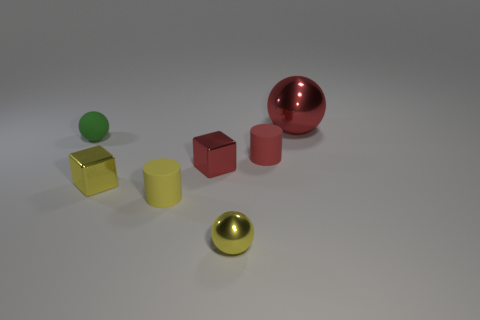Subtract all tiny spheres. How many spheres are left? 1 Add 3 matte cubes. How many objects exist? 10 Subtract all cylinders. How many objects are left? 5 Subtract all blocks. Subtract all gray matte things. How many objects are left? 5 Add 5 red matte cylinders. How many red matte cylinders are left? 6 Add 2 yellow metallic blocks. How many yellow metallic blocks exist? 3 Subtract 0 brown cylinders. How many objects are left? 7 